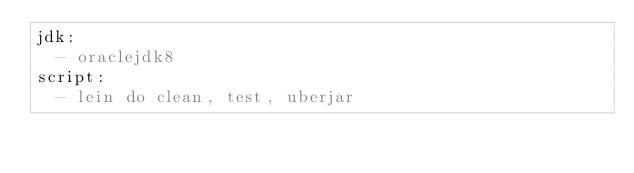Convert code to text. <code><loc_0><loc_0><loc_500><loc_500><_YAML_>jdk:
  - oraclejdk8
script:
  - lein do clean, test, uberjar
</code> 